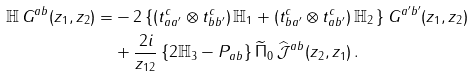<formula> <loc_0><loc_0><loc_500><loc_500>\mathbb { H } \, G ^ { a b } ( z _ { 1 } , z _ { 2 } ) = & - 2 \left \{ ( t ^ { c } _ { a a ^ { \prime } } \otimes t ^ { c } _ { b b ^ { \prime } } ) \, \mathbb { H } _ { 1 } + ( t ^ { c } _ { b a ^ { \prime } } \otimes t ^ { c } _ { a b ^ { \prime } } ) \, \mathbb { H } _ { 2 } \, \right \} G ^ { a ^ { \prime } b ^ { \prime } } ( z _ { 1 } , z _ { 2 } ) \\ & + \frac { 2 i } { z _ { 1 2 } } \left \{ 2 \mathbb { H } _ { 3 } - P _ { a b } \right \} \widetilde { \Pi } _ { 0 } \, \widehat { \mathcal { J } } ^ { a b } ( z _ { 2 } , z _ { 1 } ) \, .</formula> 